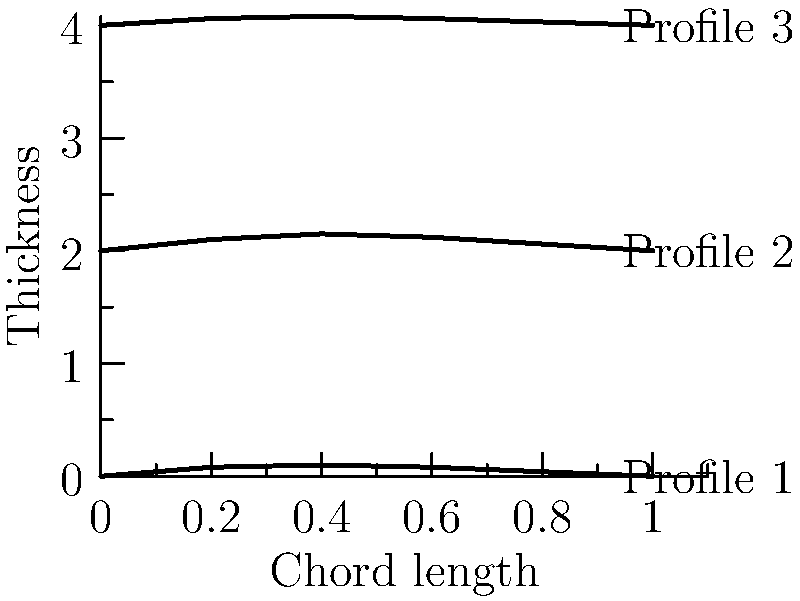Based on the blade profile diagrams shown, which wind turbine blade design is likely to have the highest efficiency for low wind speed conditions? To determine which blade profile would be most efficient for low wind speed conditions, we need to consider several factors:

1. Lift-to-drag ratio: A higher lift-to-drag ratio generally indicates better efficiency.

2. Thickness: Thicker airfoils typically generate more lift at lower speeds but also create more drag.

3. Camber: More cambered (curved) profiles generally produce more lift at lower speeds.

4. Leading edge: A more rounded leading edge helps in maintaining airflow attachment at low speeds.

Analyzing the profiles:

Profile 1: Moderate thickness and camber.
Profile 2: Thickest profile with the most pronounced camber.
Profile 3: Thinnest profile with the least camber.

For low wind speed conditions:

1. Profile 2 has the highest thickness and most pronounced camber, which would generate the most lift at low speeds.
2. The rounded leading edge of Profile 2 would help maintain airflow attachment.
3. While Profile 2 may produce more drag due to its thickness, the increased lift at low speeds would likely outweigh this disadvantage.
4. Profile 1 would be the second-best option, while Profile 3 would be more suitable for higher wind speeds.

Therefore, Profile 2 is likely to have the highest efficiency for low wind speed conditions.
Answer: Profile 2 